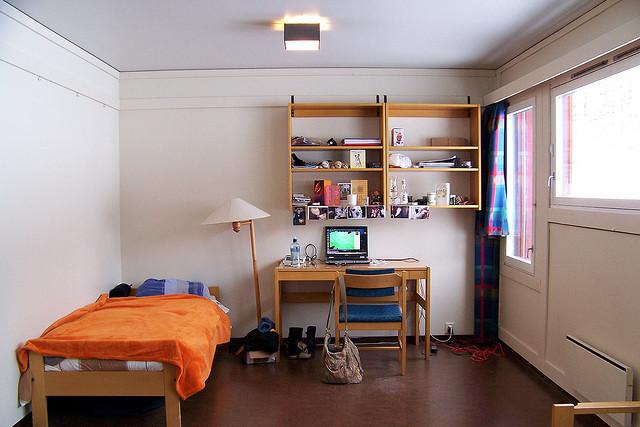Does the window have curtains?
Concise answer only. Yes. Is this a woman's room?
Keep it brief. No. Is this a bedroom?
Answer briefly. Yes. How many lights are there?
Answer briefly. 2. 